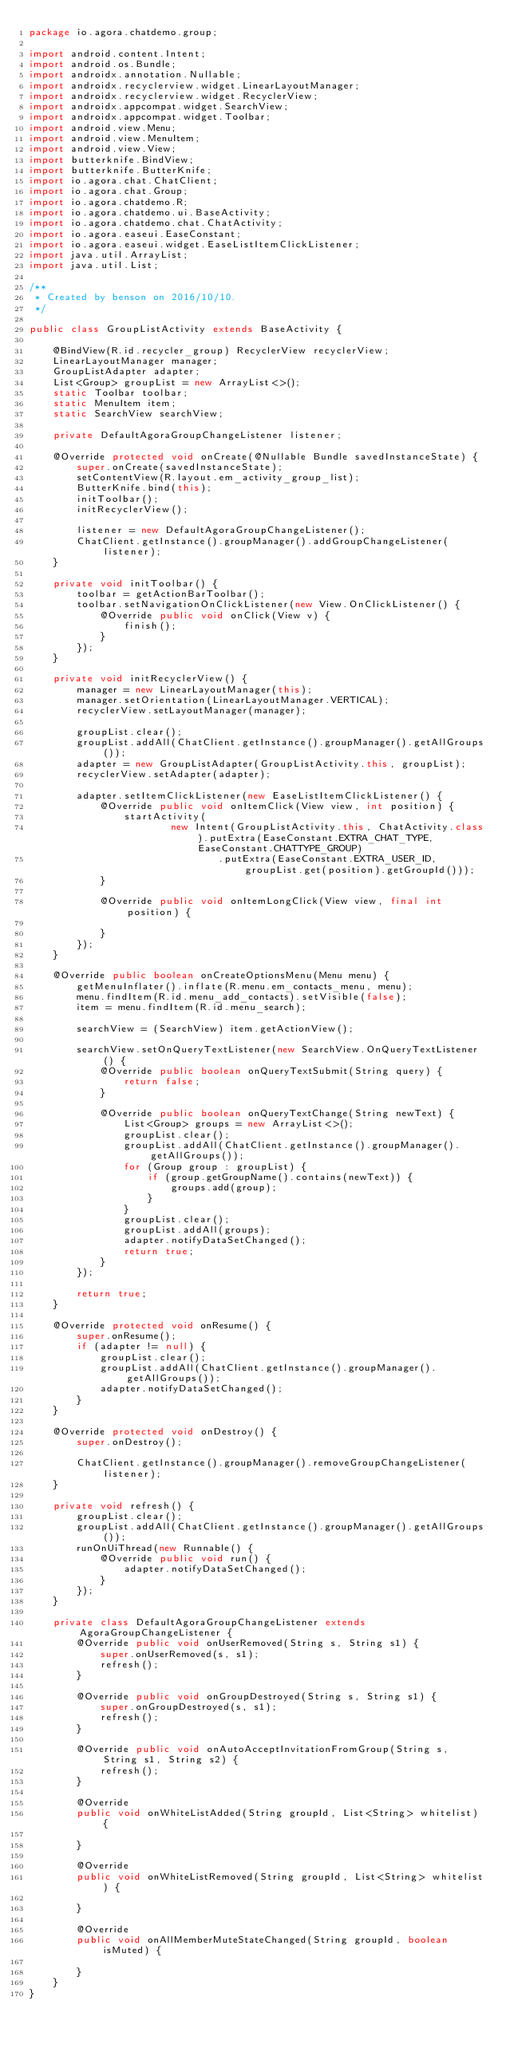<code> <loc_0><loc_0><loc_500><loc_500><_Java_>package io.agora.chatdemo.group;

import android.content.Intent;
import android.os.Bundle;
import androidx.annotation.Nullable;
import androidx.recyclerview.widget.LinearLayoutManager;
import androidx.recyclerview.widget.RecyclerView;
import androidx.appcompat.widget.SearchView;
import androidx.appcompat.widget.Toolbar;
import android.view.Menu;
import android.view.MenuItem;
import android.view.View;
import butterknife.BindView;
import butterknife.ButterKnife;
import io.agora.chat.ChatClient;
import io.agora.chat.Group;
import io.agora.chatdemo.R;
import io.agora.chatdemo.ui.BaseActivity;
import io.agora.chatdemo.chat.ChatActivity;
import io.agora.easeui.EaseConstant;
import io.agora.easeui.widget.EaseListItemClickListener;
import java.util.ArrayList;
import java.util.List;

/**
 * Created by benson on 2016/10/10.
 */

public class GroupListActivity extends BaseActivity {

    @BindView(R.id.recycler_group) RecyclerView recyclerView;
    LinearLayoutManager manager;
    GroupListAdapter adapter;
    List<Group> groupList = new ArrayList<>();
    static Toolbar toolbar;
    static MenuItem item;
    static SearchView searchView;

    private DefaultAgoraGroupChangeListener listener;

    @Override protected void onCreate(@Nullable Bundle savedInstanceState) {
        super.onCreate(savedInstanceState);
        setContentView(R.layout.em_activity_group_list);
        ButterKnife.bind(this);
        initToolbar();
        initRecyclerView();

        listener = new DefaultAgoraGroupChangeListener();
        ChatClient.getInstance().groupManager().addGroupChangeListener(listener);
    }

    private void initToolbar() {
        toolbar = getActionBarToolbar();
        toolbar.setNavigationOnClickListener(new View.OnClickListener() {
            @Override public void onClick(View v) {
                finish();
            }
        });
    }

    private void initRecyclerView() {
        manager = new LinearLayoutManager(this);
        manager.setOrientation(LinearLayoutManager.VERTICAL);
        recyclerView.setLayoutManager(manager);

        groupList.clear();
        groupList.addAll(ChatClient.getInstance().groupManager().getAllGroups());
        adapter = new GroupListAdapter(GroupListActivity.this, groupList);
        recyclerView.setAdapter(adapter);

        adapter.setItemClickListener(new EaseListItemClickListener() {
            @Override public void onItemClick(View view, int position) {
                startActivity(
                        new Intent(GroupListActivity.this, ChatActivity.class).putExtra(EaseConstant.EXTRA_CHAT_TYPE, EaseConstant.CHATTYPE_GROUP)
                                .putExtra(EaseConstant.EXTRA_USER_ID, groupList.get(position).getGroupId()));
            }

            @Override public void onItemLongClick(View view, final int position) {

            }
        });
    }

    @Override public boolean onCreateOptionsMenu(Menu menu) {
        getMenuInflater().inflate(R.menu.em_contacts_menu, menu);
        menu.findItem(R.id.menu_add_contacts).setVisible(false);
        item = menu.findItem(R.id.menu_search);

        searchView = (SearchView) item.getActionView();

        searchView.setOnQueryTextListener(new SearchView.OnQueryTextListener() {
            @Override public boolean onQueryTextSubmit(String query) {
                return false;
            }

            @Override public boolean onQueryTextChange(String newText) {
                List<Group> groups = new ArrayList<>();
                groupList.clear();
                groupList.addAll(ChatClient.getInstance().groupManager().getAllGroups());
                for (Group group : groupList) {
                    if (group.getGroupName().contains(newText)) {
                        groups.add(group);
                    }
                }
                groupList.clear();
                groupList.addAll(groups);
                adapter.notifyDataSetChanged();
                return true;
            }
        });

        return true;
    }

    @Override protected void onResume() {
        super.onResume();
        if (adapter != null) {
            groupList.clear();
            groupList.addAll(ChatClient.getInstance().groupManager().getAllGroups());
            adapter.notifyDataSetChanged();
        }
    }

    @Override protected void onDestroy() {
        super.onDestroy();

        ChatClient.getInstance().groupManager().removeGroupChangeListener(listener);
    }

    private void refresh() {
        groupList.clear();
        groupList.addAll(ChatClient.getInstance().groupManager().getAllGroups());
        runOnUiThread(new Runnable() {
            @Override public void run() {
                adapter.notifyDataSetChanged();
            }
        });
    }

    private class DefaultAgoraGroupChangeListener extends AgoraGroupChangeListener {
        @Override public void onUserRemoved(String s, String s1) {
            super.onUserRemoved(s, s1);
            refresh();
        }

        @Override public void onGroupDestroyed(String s, String s1) {
            super.onGroupDestroyed(s, s1);
            refresh();
        }

        @Override public void onAutoAcceptInvitationFromGroup(String s, String s1, String s2) {
            refresh();
        }

        @Override
        public void onWhiteListAdded(String groupId, List<String> whitelist) {

        }

        @Override
        public void onWhiteListRemoved(String groupId, List<String> whitelist) {

        }

        @Override
        public void onAllMemberMuteStateChanged(String groupId, boolean isMuted) {

        }
    }
}
</code> 